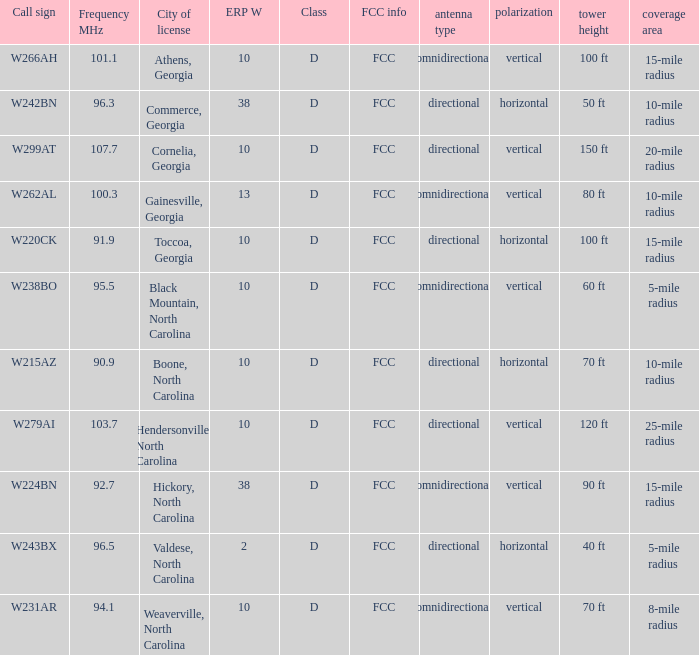What is the Frequency MHz for the station with a call sign of w224bn? 92.7. 